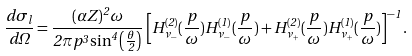<formula> <loc_0><loc_0><loc_500><loc_500>\frac { d \sigma _ { l } } { d \Omega } = \frac { ( \alpha Z ) ^ { 2 } \omega } { 2 \pi p ^ { 3 } \sin ^ { 4 } \left ( \frac { \theta } { 2 } \right ) } \left [ H ^ { ( 2 ) } _ { \nu _ { - } } ( \frac { p } { \omega } ) H ^ { ( 1 ) } _ { \nu _ { - } } ( \frac { p } { \omega } ) + H ^ { ( 2 ) } _ { \nu _ { + } } ( \frac { p } { \omega } ) H ^ { ( 1 ) } _ { \nu _ { + } } ( \frac { p } { \omega } ) \right ] ^ { - 1 } .</formula> 